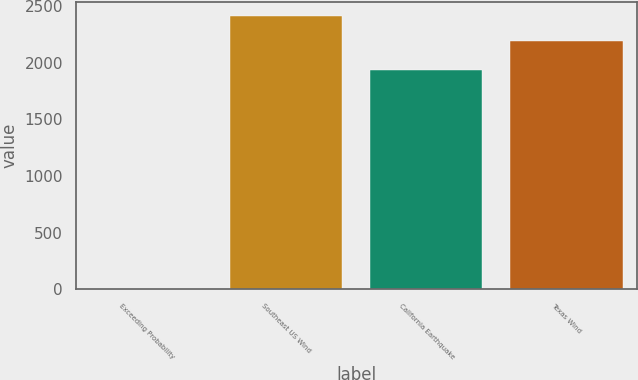Convert chart. <chart><loc_0><loc_0><loc_500><loc_500><bar_chart><fcel>Exceeding Probability<fcel>Southeast US Wind<fcel>California Earthquake<fcel>Texas Wind<nl><fcel>0.1<fcel>2415.79<fcel>1939<fcel>2190<nl></chart> 